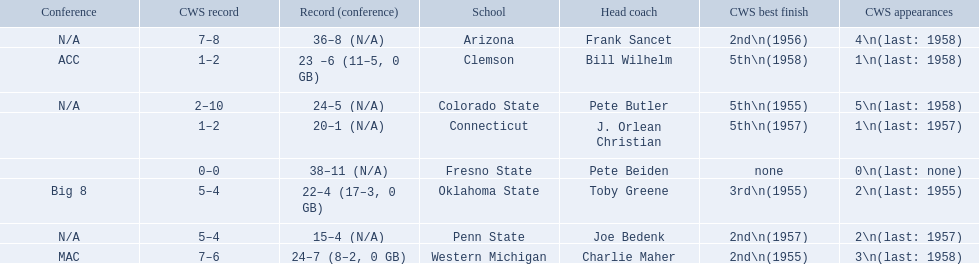Which teams played in the 1959 ncaa university division baseball tournament? Arizona, Clemson, Colorado State, Connecticut, Fresno State, Oklahoma State, Penn State, Western Michigan. Which was the only one to win less than 20 games? Penn State. 